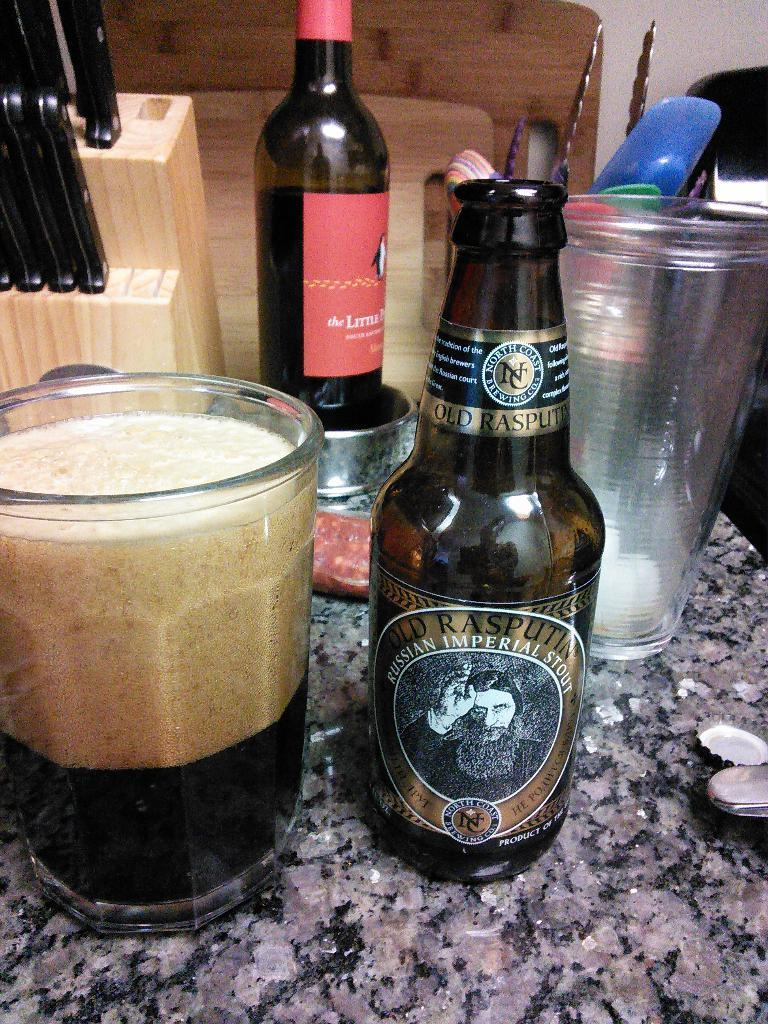<image>
Share a concise interpretation of the image provided. Bottle of beer called "Old Rasputin" next to a cup of beer. 